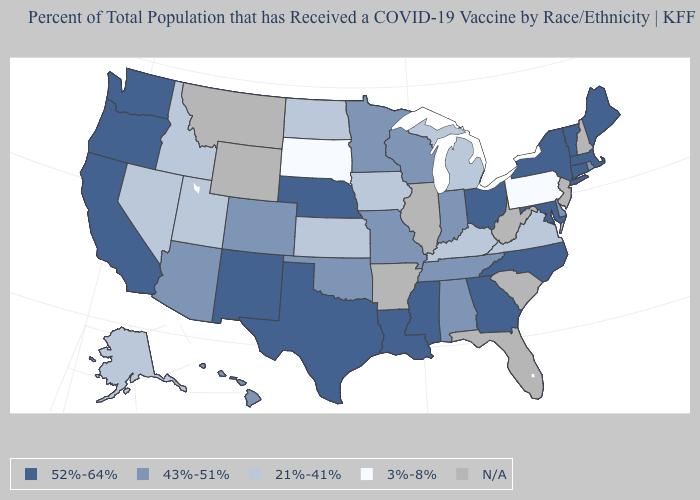What is the value of Connecticut?
Give a very brief answer. 52%-64%. Among the states that border Colorado , which have the lowest value?
Keep it brief. Kansas, Utah. Is the legend a continuous bar?
Quick response, please. No. Is the legend a continuous bar?
Be succinct. No. What is the value of Alaska?
Answer briefly. 21%-41%. Does Pennsylvania have the lowest value in the Northeast?
Give a very brief answer. Yes. Name the states that have a value in the range 52%-64%?
Quick response, please. California, Connecticut, Georgia, Louisiana, Maine, Maryland, Massachusetts, Mississippi, Nebraska, New Mexico, New York, North Carolina, Ohio, Oregon, Texas, Vermont, Washington. What is the highest value in the USA?
Give a very brief answer. 52%-64%. Does the map have missing data?
Short answer required. Yes. Among the states that border Tennessee , does Georgia have the highest value?
Quick response, please. Yes. What is the value of Arkansas?
Be succinct. N/A. What is the lowest value in the USA?
Quick response, please. 3%-8%. Among the states that border Mississippi , does Louisiana have the highest value?
Answer briefly. Yes. What is the value of Texas?
Be succinct. 52%-64%. 